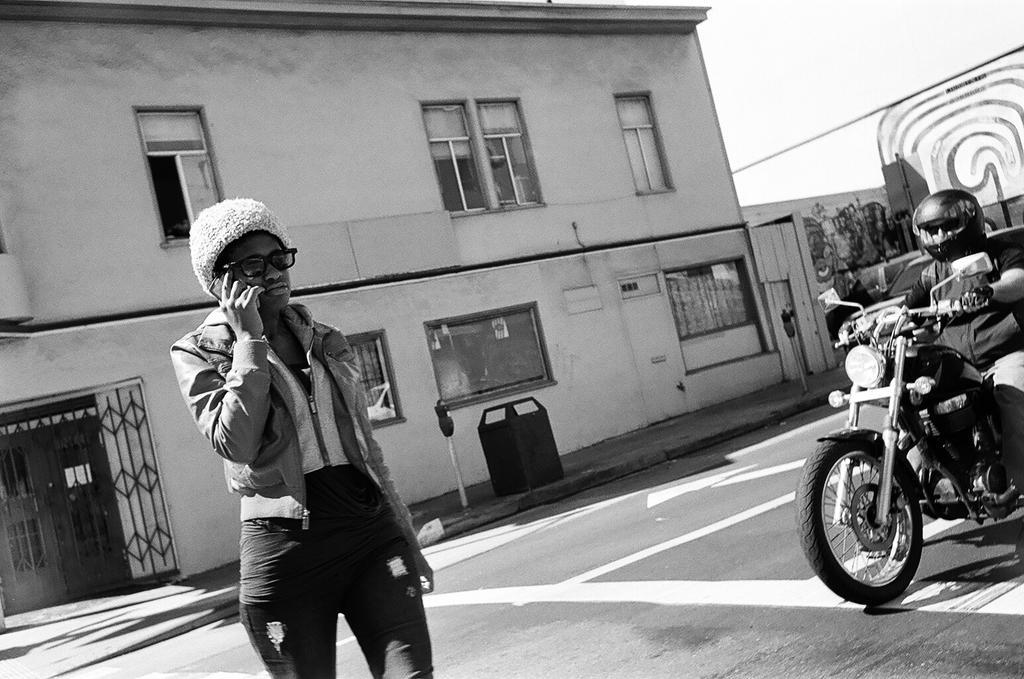Can you describe this image briefly? This is a black and white image. There is a building on the backside. There are two persons in this image one is sitting on the bike, other one is standing. There are windows to that building. 